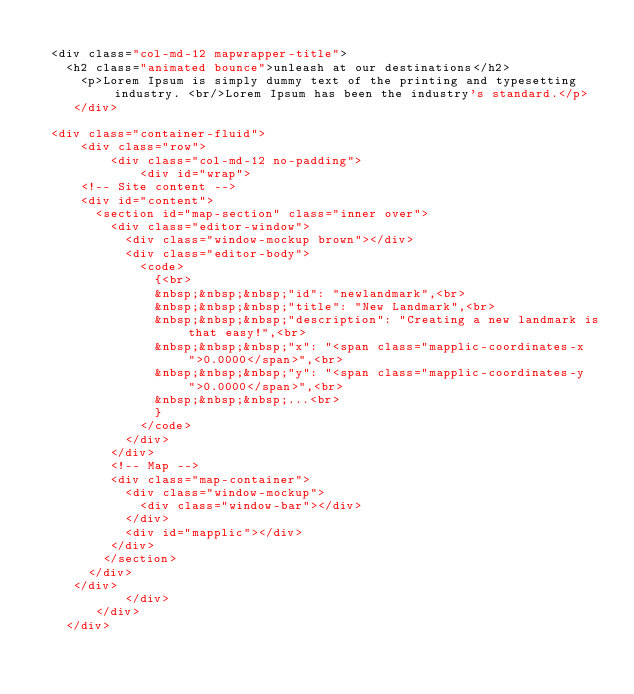Convert code to text. <code><loc_0><loc_0><loc_500><loc_500><_PHP_>
  <div class="col-md-12 mapwrapper-title">
    <h2 class="animated bounce">unleash at our destinations</h2>
      <p>Lorem Ipsum is simply dummy text of the printing and typesetting industry. <br/>Lorem Ipsum has been the industry's standard.</p>
     </div>

  <div class="container-fluid">
      <div class="row">
          <div class="col-md-12 no-padding">
              <div id="wrap">
      <!-- Site content -->
      <div id="content">
        <section id="map-section" class="inner over">
          <div class="editor-window">
            <div class="window-mockup brown"></div>
            <div class="editor-body">
              <code>
                {<br>
                &nbsp;&nbsp;&nbsp;"id": "newlandmark",<br>
                &nbsp;&nbsp;&nbsp;"title": "New Landmark",<br>
                &nbsp;&nbsp;&nbsp;"description": "Creating a new landmark is that easy!",<br>
                &nbsp;&nbsp;&nbsp;"x": "<span class="mapplic-coordinates-x">0.0000</span>",<br>
                &nbsp;&nbsp;&nbsp;"y": "<span class="mapplic-coordinates-y">0.0000</span>",<br>
                &nbsp;&nbsp;&nbsp;...<br>
                }
              </code>
            </div>
          </div>
          <!-- Map -->
          <div class="map-container">
            <div class="window-mockup">
              <div class="window-bar"></div>
            </div>
            <div id="mapplic"></div>
          </div>
         </section>
       </div>
     </div>
            </div>
        </div>
    </div>
</code> 